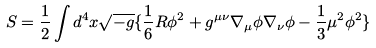<formula> <loc_0><loc_0><loc_500><loc_500>S = \frac { 1 } { 2 } \int d ^ { 4 } x \sqrt { - g } \{ \frac { 1 } { 6 } R \phi ^ { 2 } + g ^ { \mu \nu } \nabla _ { \mu } \phi \nabla _ { \nu } \phi - \frac { 1 } { 3 } \mu ^ { 2 } \phi ^ { 2 } \}</formula> 